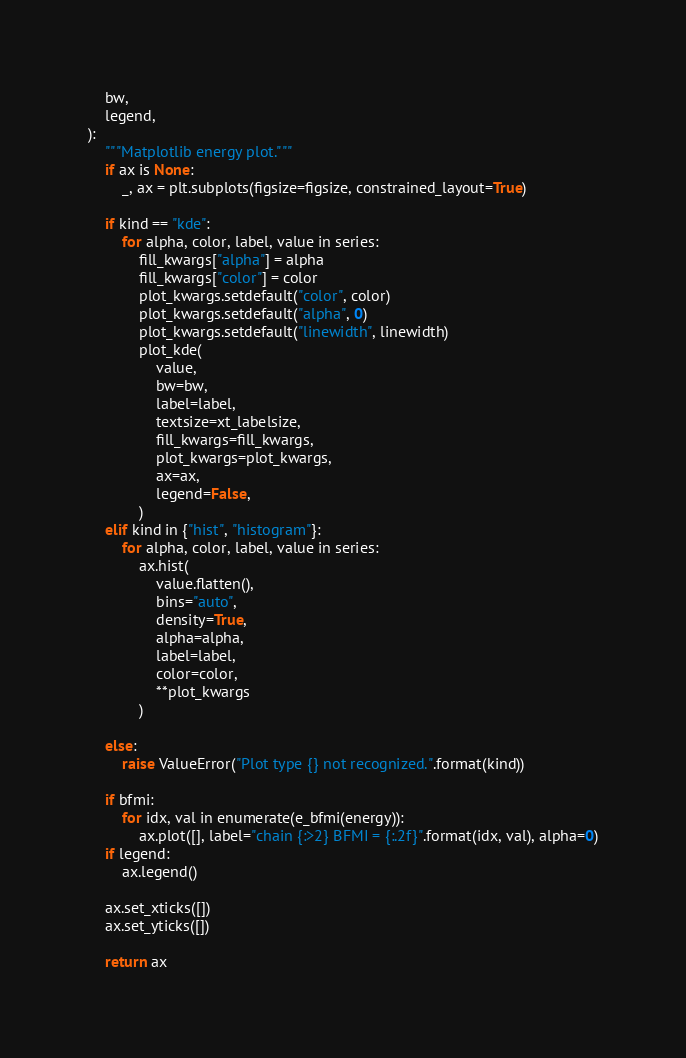Convert code to text. <code><loc_0><loc_0><loc_500><loc_500><_Python_>    bw,
    legend,
):
    """Matplotlib energy plot."""
    if ax is None:
        _, ax = plt.subplots(figsize=figsize, constrained_layout=True)

    if kind == "kde":
        for alpha, color, label, value in series:
            fill_kwargs["alpha"] = alpha
            fill_kwargs["color"] = color
            plot_kwargs.setdefault("color", color)
            plot_kwargs.setdefault("alpha", 0)
            plot_kwargs.setdefault("linewidth", linewidth)
            plot_kde(
                value,
                bw=bw,
                label=label,
                textsize=xt_labelsize,
                fill_kwargs=fill_kwargs,
                plot_kwargs=plot_kwargs,
                ax=ax,
                legend=False,
            )
    elif kind in {"hist", "histogram"}:
        for alpha, color, label, value in series:
            ax.hist(
                value.flatten(),
                bins="auto",
                density=True,
                alpha=alpha,
                label=label,
                color=color,
                **plot_kwargs
            )

    else:
        raise ValueError("Plot type {} not recognized.".format(kind))

    if bfmi:
        for idx, val in enumerate(e_bfmi(energy)):
            ax.plot([], label="chain {:>2} BFMI = {:.2f}".format(idx, val), alpha=0)
    if legend:
        ax.legend()

    ax.set_xticks([])
    ax.set_yticks([])

    return ax
</code> 